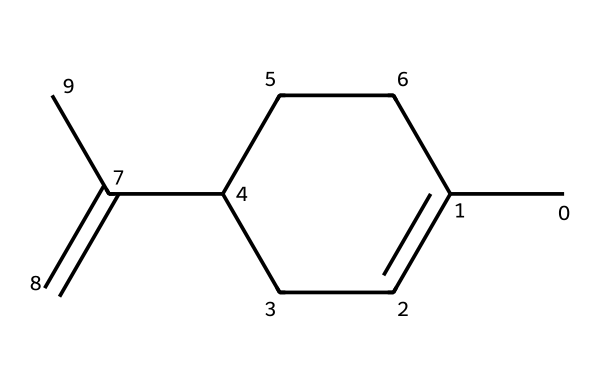What is the name of this chemical? The SMILES code given represents the molecular structure of limonene, which is widely known for its characteristic citrus scent.
Answer: limonene How many carbon atoms are in limonene? By examining the structure represented in the SMILES string, we can count the "C" symbols, which indicate carbon atoms. There are 10 carbon atoms in limonene.
Answer: 10 What type of hydrocarbon is limonene? Limonene is classified as a monoterpene, which consists of 10 carbon atoms and is typically derived from plant sources, particularly citrus fruits.
Answer: monoterpene Does limonene contain any double bonds? Analyzing the structure reveals that there are at least two double bonds (C=C) present in limonene, contributing to its unsaturation.
Answer: yes How many hydrogen atoms are in limonene? The number of hydrogen atoms in limonene can be calculated based on its molecular formula, C10H16, which shows that there are a total of 16 hydrogen atoms.
Answer: 16 What is the main functional group associated with limonene's fragrance? The structure features alkenyl groups (double bonds), which are characteristic in compounds that contribute to fragrance, as they often create volatile compounds that are important for scent.
Answer: alkenyl What might be the effect of the double bonds on limonene's properties? The presence of double bonds in limonene introduces reactivity to the molecule, making it more susceptible to oxidation and also contributing to its volatility, which enhances its aroma.
Answer: reactivity 